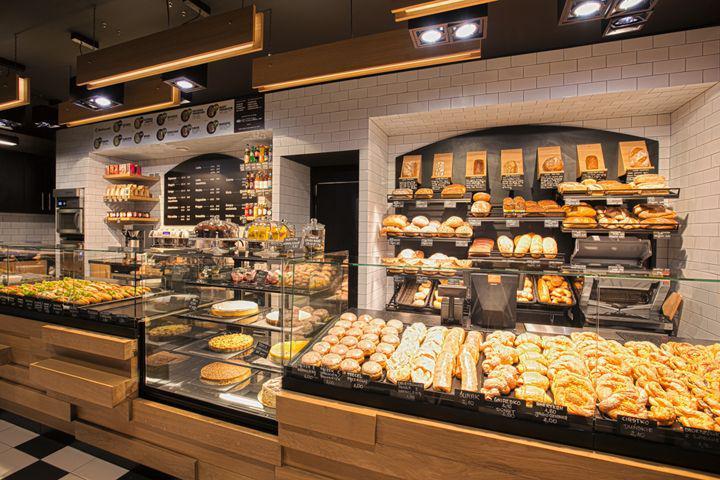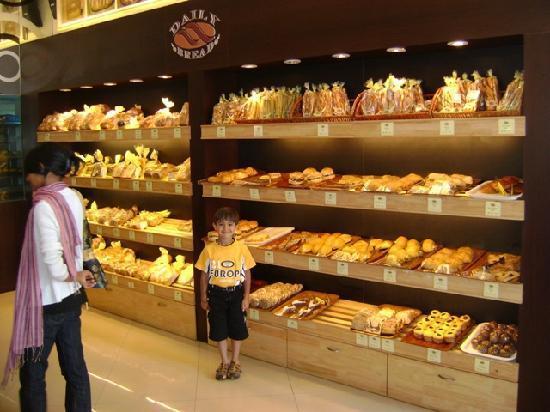The first image is the image on the left, the second image is the image on the right. Assess this claim about the two images: "At least one person is near bread products in one image.". Correct or not? Answer yes or no. Yes. The first image is the image on the left, the second image is the image on the right. Assess this claim about the two images: "There are many loaves of bread in the image on the right". Correct or not? Answer yes or no. Yes. The first image is the image on the left, the second image is the image on the right. Given the left and right images, does the statement "There is at least one purple label in one of the images." hold true? Answer yes or no. No. The first image is the image on the left, the second image is the image on the right. Analyze the images presented: Is the assertion "At least one image includes lights above the bakery displays." valid? Answer yes or no. Yes. 